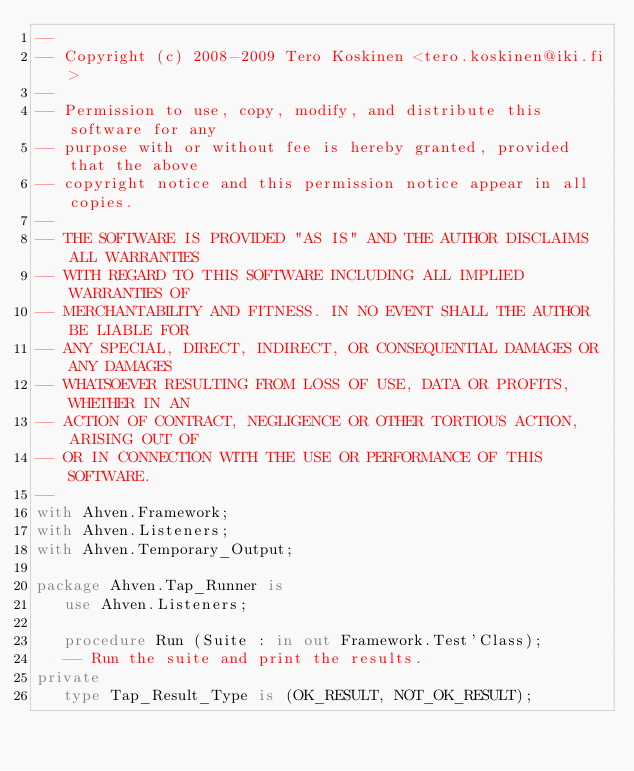Convert code to text. <code><loc_0><loc_0><loc_500><loc_500><_Ada_>--
-- Copyright (c) 2008-2009 Tero Koskinen <tero.koskinen@iki.fi>
--
-- Permission to use, copy, modify, and distribute this software for any
-- purpose with or without fee is hereby granted, provided that the above
-- copyright notice and this permission notice appear in all copies.
--
-- THE SOFTWARE IS PROVIDED "AS IS" AND THE AUTHOR DISCLAIMS ALL WARRANTIES
-- WITH REGARD TO THIS SOFTWARE INCLUDING ALL IMPLIED WARRANTIES OF
-- MERCHANTABILITY AND FITNESS. IN NO EVENT SHALL THE AUTHOR BE LIABLE FOR
-- ANY SPECIAL, DIRECT, INDIRECT, OR CONSEQUENTIAL DAMAGES OR ANY DAMAGES
-- WHATSOEVER RESULTING FROM LOSS OF USE, DATA OR PROFITS, WHETHER IN AN
-- ACTION OF CONTRACT, NEGLIGENCE OR OTHER TORTIOUS ACTION, ARISING OUT OF
-- OR IN CONNECTION WITH THE USE OR PERFORMANCE OF THIS SOFTWARE.
--
with Ahven.Framework;
with Ahven.Listeners;
with Ahven.Temporary_Output;

package Ahven.Tap_Runner is
   use Ahven.Listeners;

   procedure Run (Suite : in out Framework.Test'Class);
   -- Run the suite and print the results.
private
   type Tap_Result_Type is (OK_RESULT, NOT_OK_RESULT);
</code> 